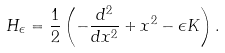Convert formula to latex. <formula><loc_0><loc_0><loc_500><loc_500>H _ { \epsilon } = \frac { 1 } { 2 } \left ( - \frac { d ^ { 2 } } { d x ^ { 2 } } + x ^ { 2 } - \epsilon K \right ) .</formula> 